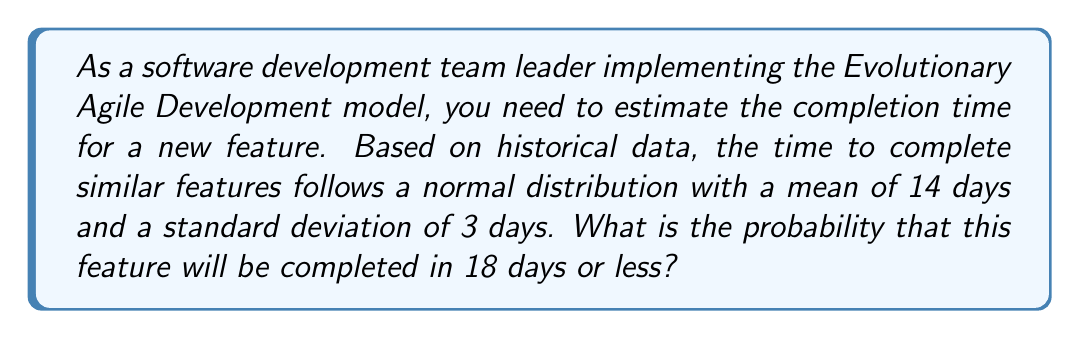Solve this math problem. To solve this problem, we need to use the properties of the normal distribution and calculate the z-score for the given value. Then, we'll use a standard normal distribution table or the cumulative distribution function to find the probability.

Step 1: Identify the given information
- Mean (μ) = 14 days
- Standard deviation (σ) = 3 days
- Time in question (x) = 18 days

Step 2: Calculate the z-score
The z-score formula is:
$$ z = \frac{x - \mu}{\sigma} $$

Plugging in the values:
$$ z = \frac{18 - 14}{3} = \frac{4}{3} \approx 1.33 $$

Step 3: Use the standard normal distribution table or cumulative distribution function
For z = 1.33, the corresponding probability is approximately 0.9082.

This means that the probability of completing the feature in 18 days or less is about 0.9082 or 90.82%.

Step 4: Interpret the result
There is a 90.82% chance that the feature will be completed in 18 days or less, given the normal distribution of completion times for similar features.
Answer: 0.9082 (or 90.82%) 